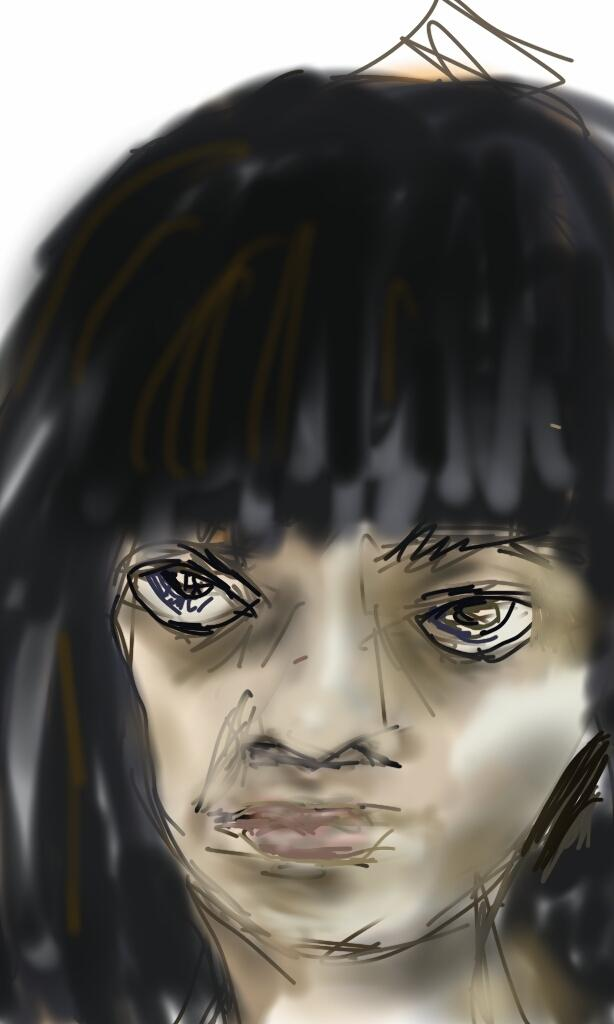What type of artwork is depicted in the image? The image contains a sketch. How many mice are interacting with the mother plant in the image? There are no mice or plants present in the image; it contains a sketch. 